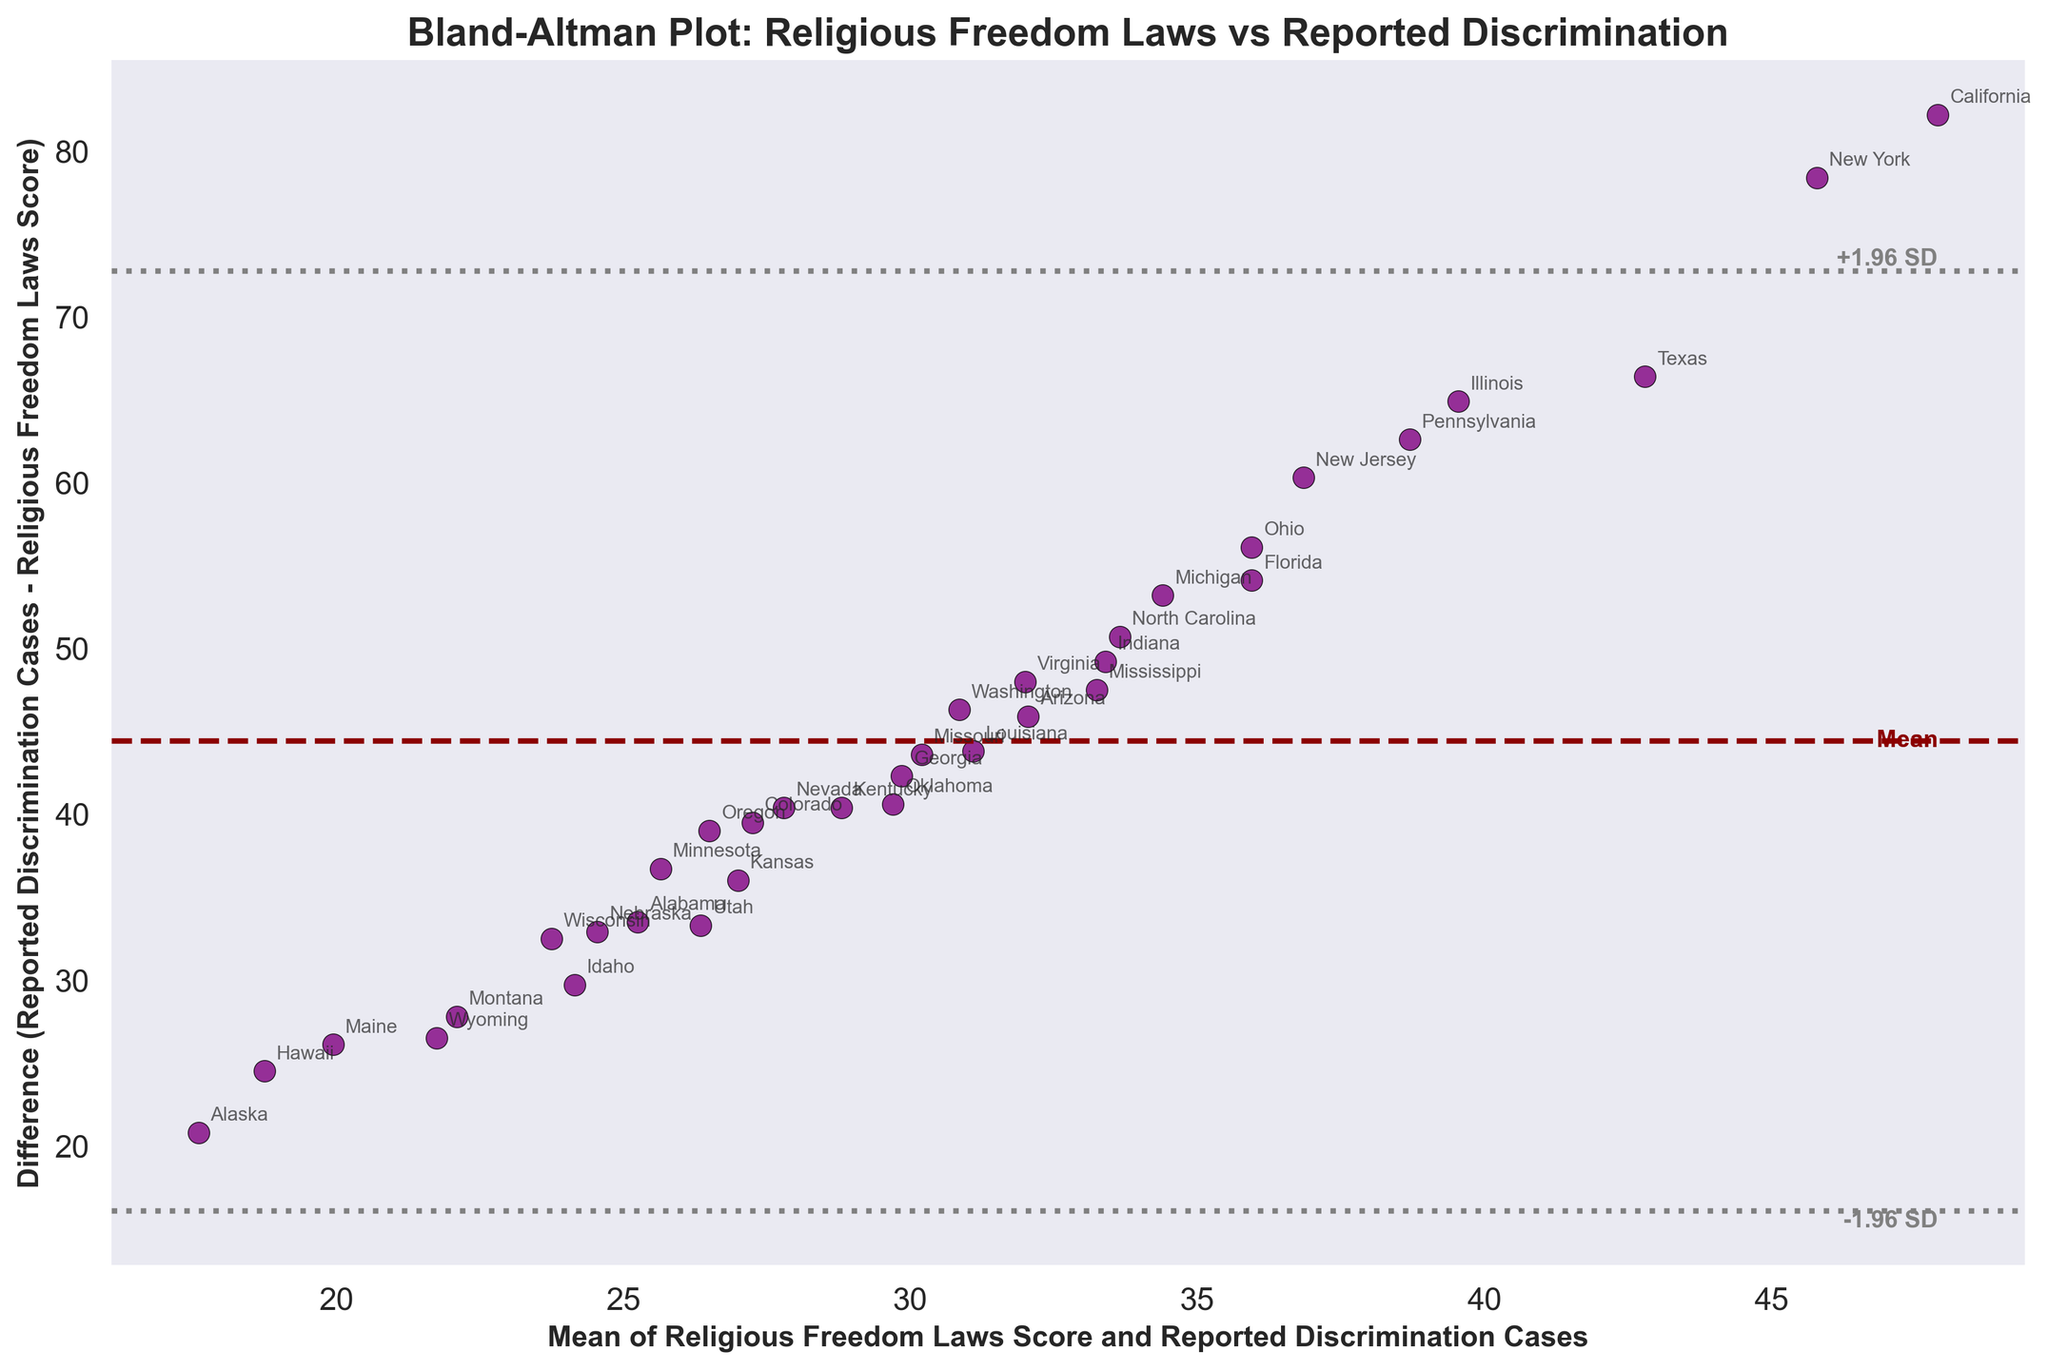What is the title of the figure? The title of the figure is usually placed at the top and helps in understanding the content being depicted. Reading the figure's title, which is located at the top center of the plot, will give the needed information.
Answer: Bland-Altman Plot: Religious Freedom Laws vs Reported Discrimination What do the solid and dashed lines on the plot represent? In a Bland–Altman plot, the solid line represents the mean difference between the two sets of measurements, and the dashed lines represent ±1.96 times the standard deviation of the differences. This helps to observe any systematic bias and the limits of agreement.
Answer: The solid line represents the mean difference, and the dashed lines represent ±1.96 times the standard deviation How many States are included in this analysis? Each state is represented by a data point on the plot, accompanied by an annotation. By counting the number of unique annotations, we determine the number of states included.
Answer: 34 What is the mean difference between the Religious Freedom Laws Score and Reported Discrimination Cases? The mean difference is indicated by the horizontal solid line labeled "Mean". The value where this line intersects the y-axis provides the mean difference.
Answer: Approximately 36.5 Which State shows the largest disparity between the Religious Freedom Laws Score and Reported Discrimination Cases? To find the state with the largest disparity, look for the data point with the maximum or minimum difference plotted on the y-axis. The annotated state with this data point will indicate the state with the largest disparity.
Answer: California For which states is the difference between Religious Freedom Laws Scores and Reported Discrimination Cases closest to the mean difference? Find the data points that lie closest to the solid horizontal line representing the mean difference. Look for the annotations of these points to identify the states.
Answer: Colorado, Georgia What can be inferred if a state's data point lies outside the dashed lines? In a Bland–Altman plot, data points outside the dashed lines (±1.96 SD) suggest that the agreement between the two measurements for those points is unusually poor or there might be anomalies.
Answer: Poor agreement or anomalies Which states' data points fall above the upper 1.96 SD line? Identify the data points that are above the upper dashed line and note the annotations associated with these points. These are the states showing a higher than expected reported discrimination cases compared to religious freedom scores.
Answer: California, New York, Texas Are there any states where the reported discrimination cases are almost equal to the religious freedom laws score? Look for data points that align close to the y-axis value of 0, which denotes almost no difference between the reported discrimination cases and religious freedom laws score.
Answer: Idaho, Utah What is the average of the means of Religious Freedom Laws Score and Reported Discrimination Cases? The x-axis represents the means of the two measurements. To find the average of these means across all data points, sum all the x-axis values and divide by the number of states.
Answer: Approximately 38.65 